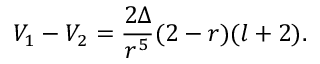Convert formula to latex. <formula><loc_0><loc_0><loc_500><loc_500>V _ { 1 } - V _ { 2 } = \frac { 2 \Delta } { r ^ { 5 } } ( 2 - r ) ( l + 2 ) .</formula> 